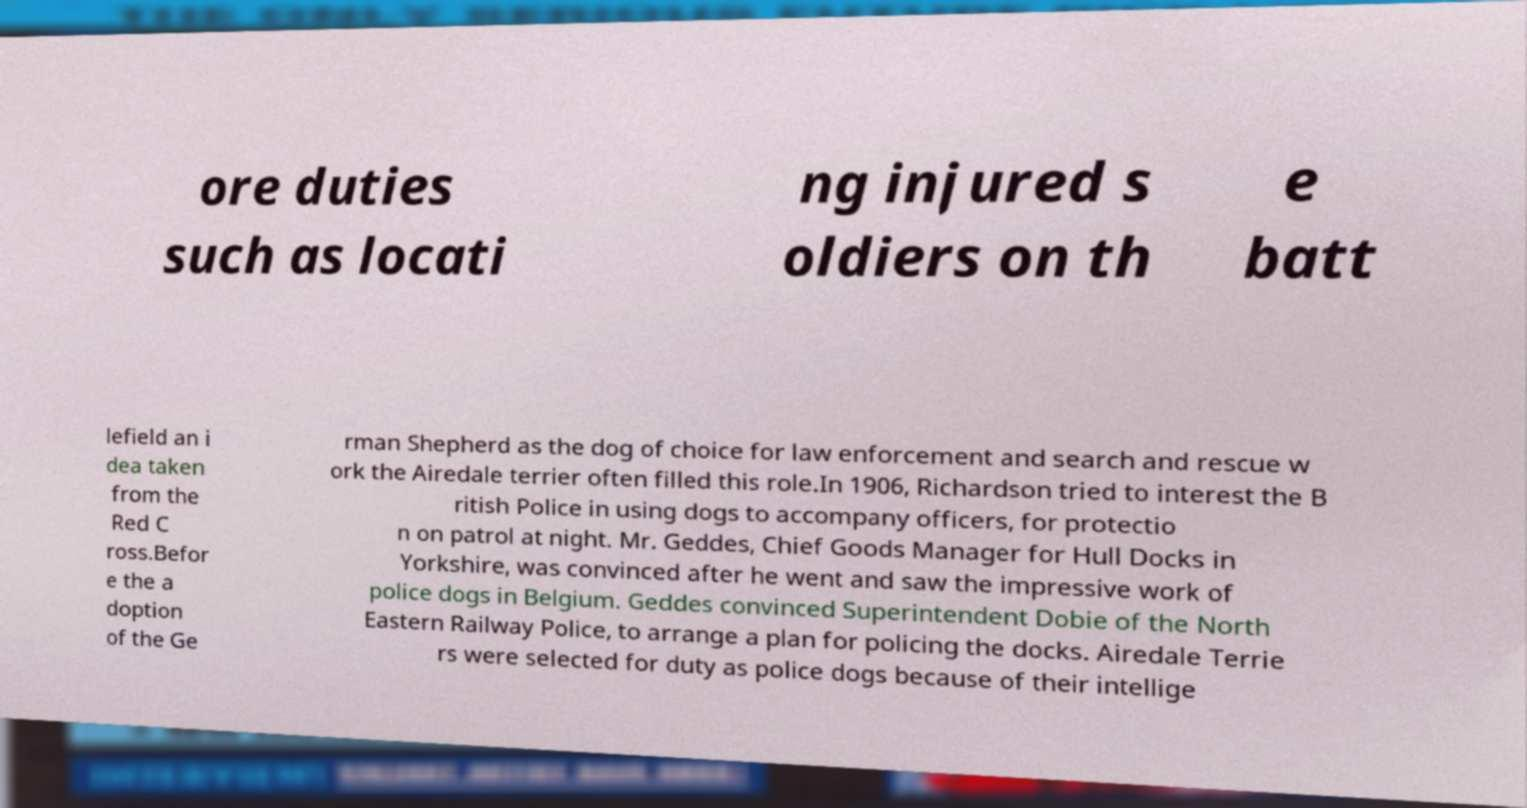Could you extract and type out the text from this image? ore duties such as locati ng injured s oldiers on th e batt lefield an i dea taken from the Red C ross.Befor e the a doption of the Ge rman Shepherd as the dog of choice for law enforcement and search and rescue w ork the Airedale terrier often filled this role.In 1906, Richardson tried to interest the B ritish Police in using dogs to accompany officers, for protectio n on patrol at night. Mr. Geddes, Chief Goods Manager for Hull Docks in Yorkshire, was convinced after he went and saw the impressive work of police dogs in Belgium. Geddes convinced Superintendent Dobie of the North Eastern Railway Police, to arrange a plan for policing the docks. Airedale Terrie rs were selected for duty as police dogs because of their intellige 